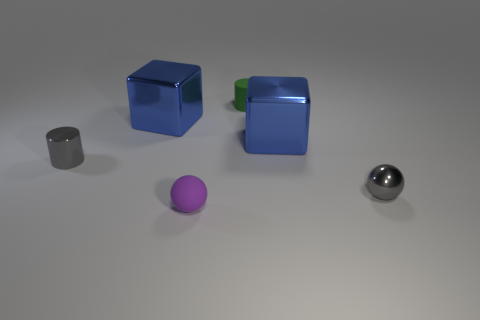How many blue cubes must be subtracted to get 1 blue cubes? 1 Subtract all cubes. How many objects are left? 4 Subtract all purple cylinders. Subtract all brown spheres. How many cylinders are left? 2 Subtract all blue spheres. How many cyan cylinders are left? 0 Subtract all gray rubber objects. Subtract all metallic cylinders. How many objects are left? 5 Add 1 small green matte cylinders. How many small green matte cylinders are left? 2 Add 4 big cyan shiny spheres. How many big cyan shiny spheres exist? 4 Add 2 small purple spheres. How many objects exist? 8 Subtract 1 gray cylinders. How many objects are left? 5 